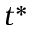Convert formula to latex. <formula><loc_0><loc_0><loc_500><loc_500>t ^ { * }</formula> 